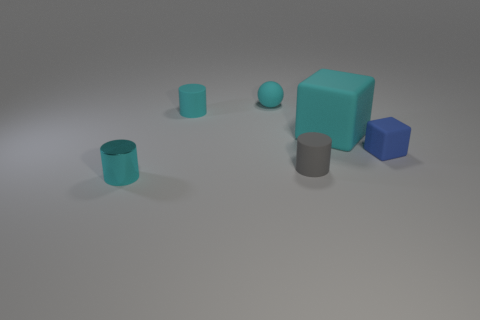What is the color of the small object that is behind the small cyan matte cylinder?
Keep it short and to the point. Cyan. What number of other things are the same color as the large block?
Your response must be concise. 3. Are there any other things that are the same size as the blue rubber thing?
Make the answer very short. Yes. There is a cylinder on the right side of the matte ball; is it the same size as the small cyan rubber ball?
Your answer should be very brief. Yes. There is a cyan cylinder that is behind the small metallic object; what is it made of?
Offer a terse response. Rubber. Is there any other thing that has the same shape as the big cyan object?
Your response must be concise. Yes. What number of matte things are either large blue cylinders or cyan objects?
Your response must be concise. 3. Is the number of small cyan rubber spheres in front of the gray matte cylinder less than the number of large blue cylinders?
Provide a short and direct response. No. What shape is the cyan matte object that is right of the small gray object that is in front of the small cyan cylinder that is behind the tiny cyan shiny cylinder?
Make the answer very short. Cube. Do the rubber ball and the large cube have the same color?
Make the answer very short. Yes. 